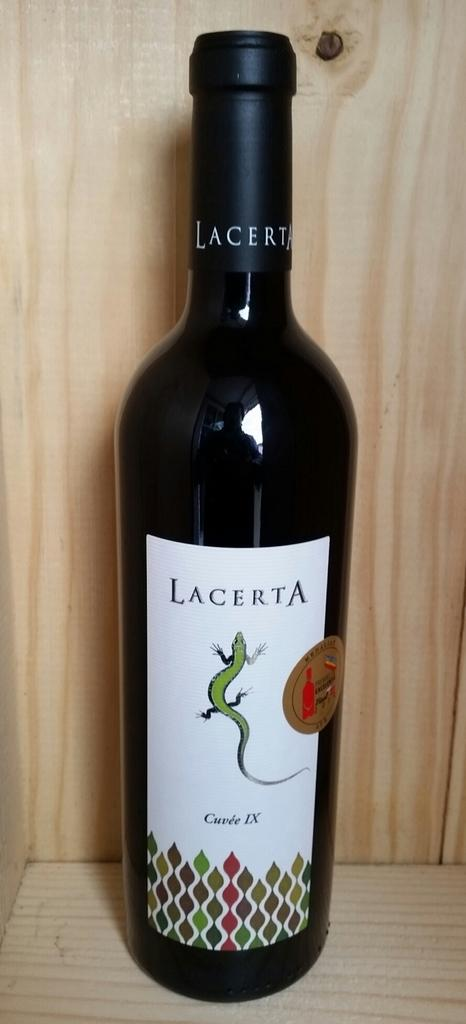Provide a one-sentence caption for the provided image. A wooden table or box,and a wine bottle with a lizard and the name Lacerta. 